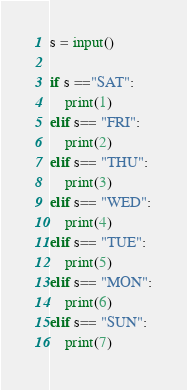Convert code to text. <code><loc_0><loc_0><loc_500><loc_500><_Python_>s = input()

if s =="SAT":
    print(1)
elif s== "FRI":
    print(2)
elif s== "THU":
    print(3)
elif s== "WED":
    print(4)
elif s== "TUE":
    print(5)
elif s== "MON":
    print(6)
elif s== "SUN":
    print(7)
</code> 